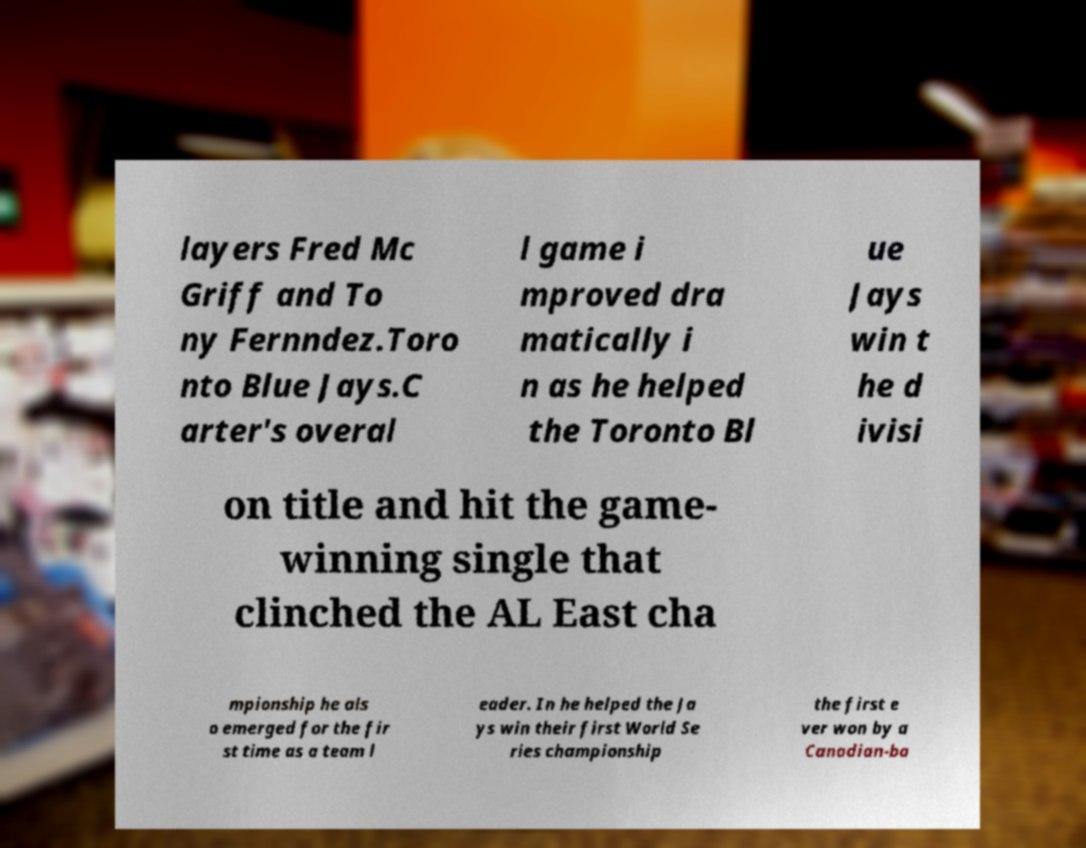There's text embedded in this image that I need extracted. Can you transcribe it verbatim? layers Fred Mc Griff and To ny Fernndez.Toro nto Blue Jays.C arter's overal l game i mproved dra matically i n as he helped the Toronto Bl ue Jays win t he d ivisi on title and hit the game- winning single that clinched the AL East cha mpionship he als o emerged for the fir st time as a team l eader. In he helped the Ja ys win their first World Se ries championship the first e ver won by a Canadian-ba 